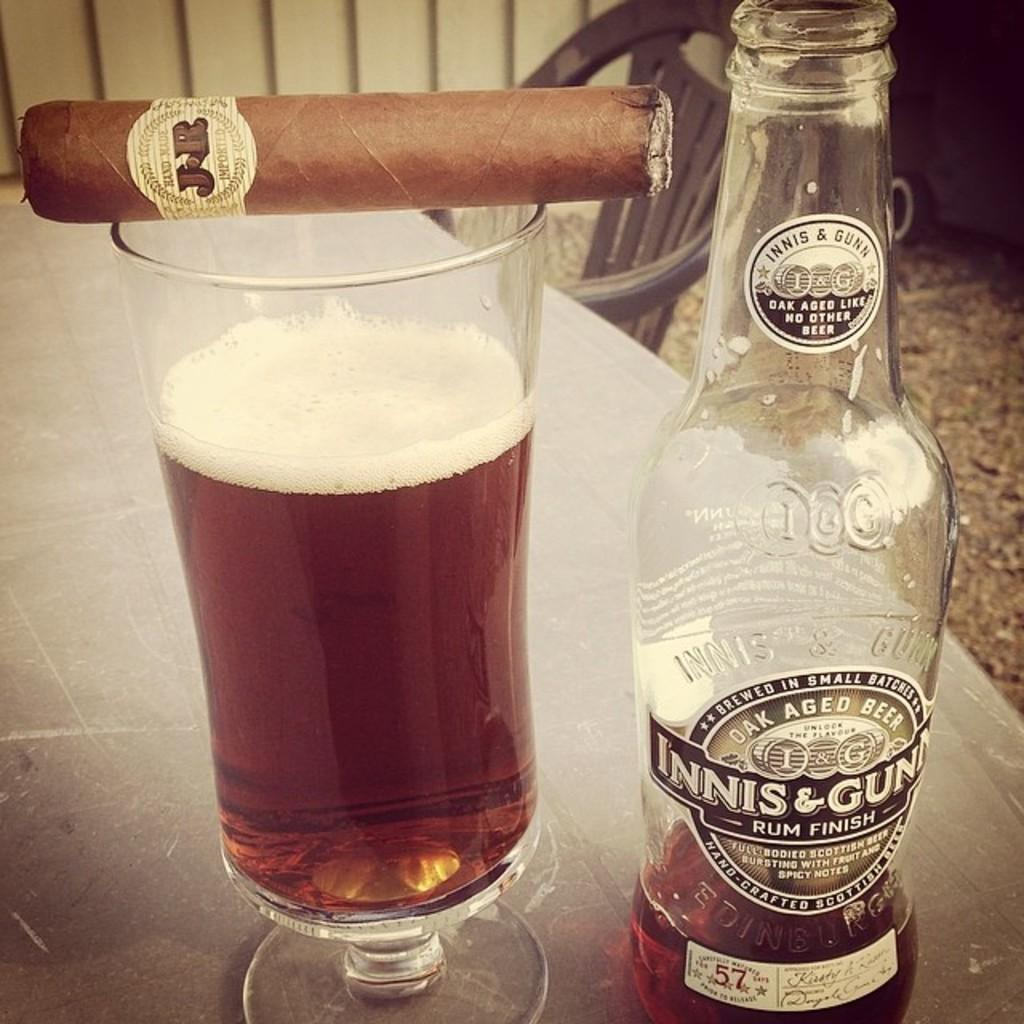<image>
Share a concise interpretation of the image provided. J&R cigar laying on top of a almost full glass of rum, next to it is an almost empty bottle of rum 